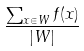<formula> <loc_0><loc_0><loc_500><loc_500>\frac { \sum _ { x \in W } f ( x ) } { | W | }</formula> 